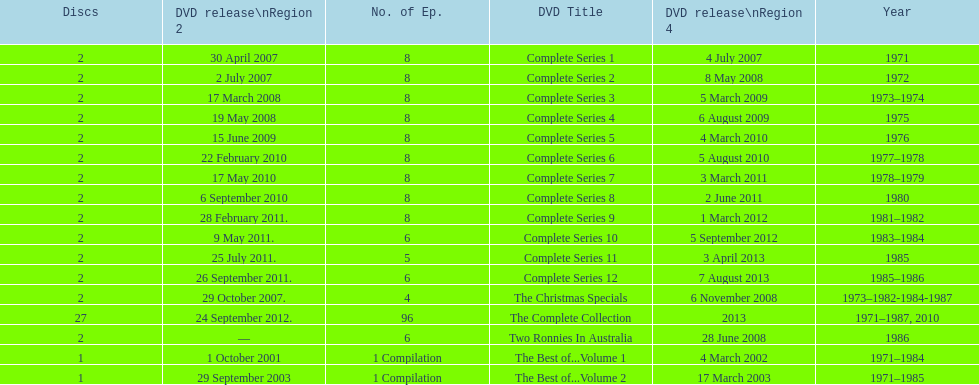How many "best of" volumes compile the top episodes of the television show "the two ronnies". 2. 